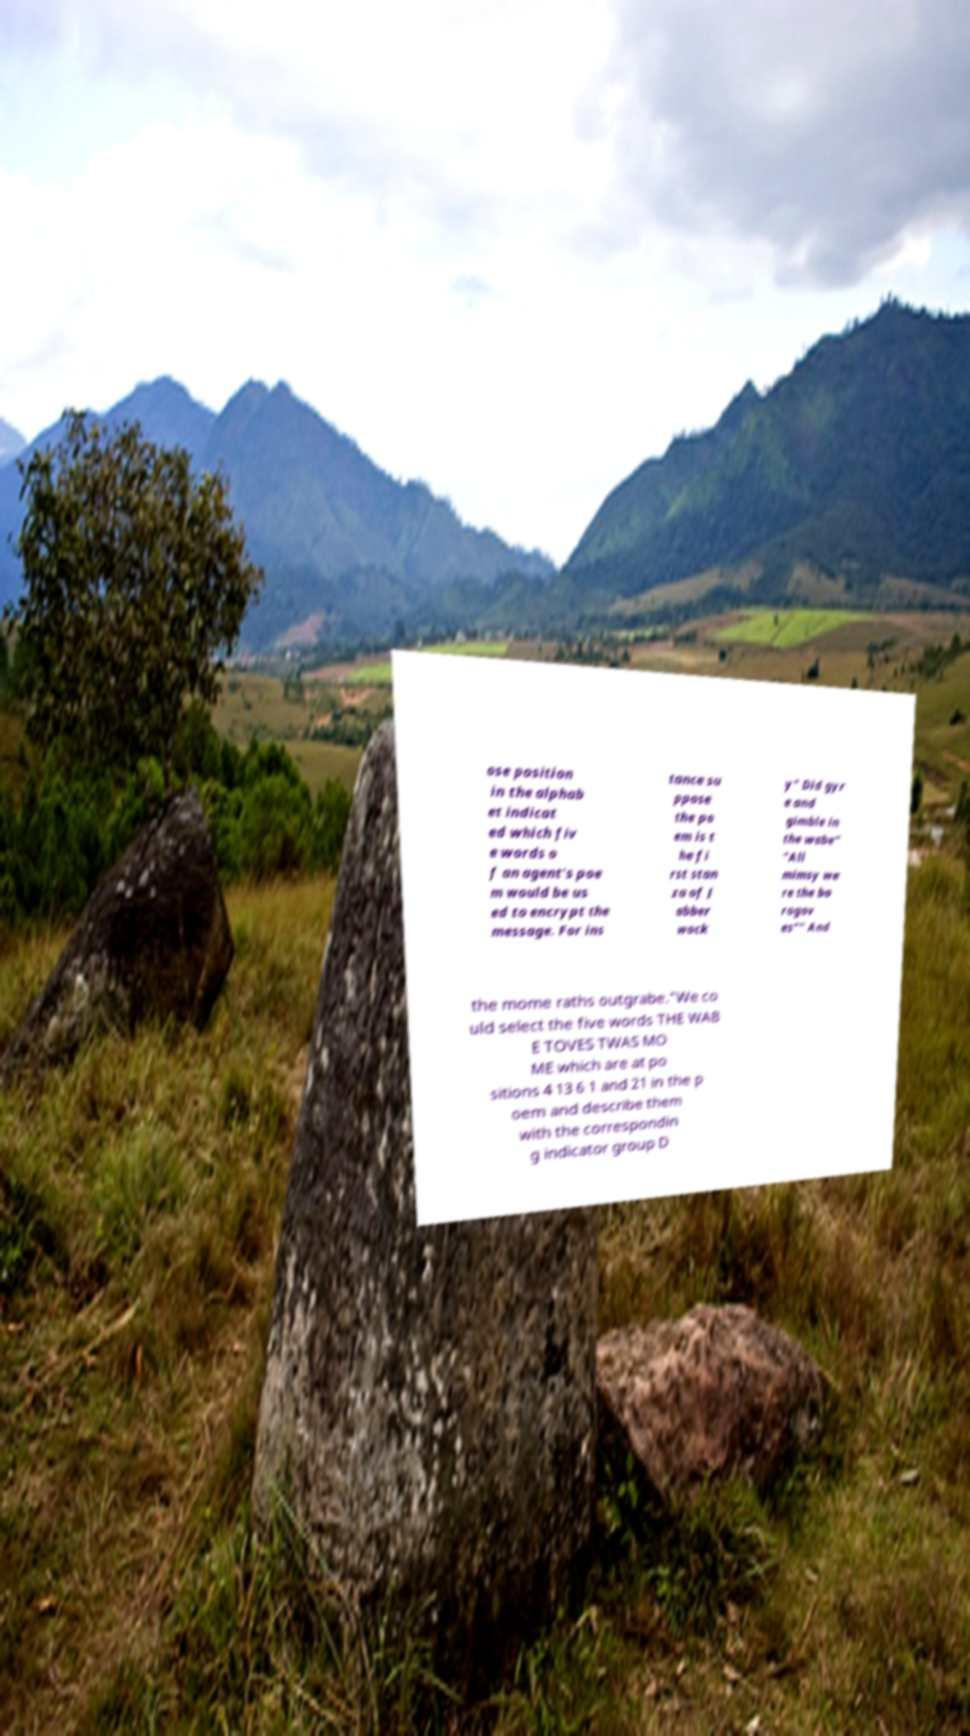Could you assist in decoding the text presented in this image and type it out clearly? ose position in the alphab et indicat ed which fiv e words o f an agent's poe m would be us ed to encrypt the message. For ins tance su ppose the po em is t he fi rst stan za of J abber wock y" Did gyr e and gimble in the wabe" "All mimsy we re the bo rogov es"" And the mome raths outgrabe."We co uld select the five words THE WAB E TOVES TWAS MO ME which are at po sitions 4 13 6 1 and 21 in the p oem and describe them with the correspondin g indicator group D 